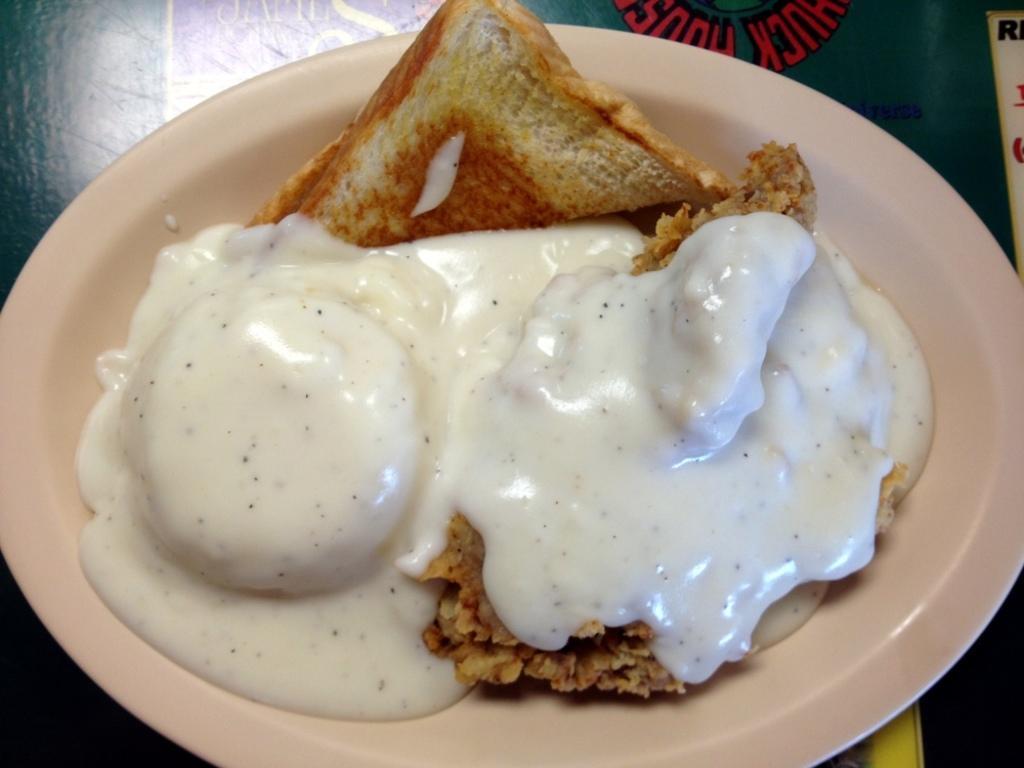Describe this image in one or two sentences. In this image I can see the green colored surface and on it I can see a cream colored plate and on the plate I can see a food item which is brown, cream and white in color. 